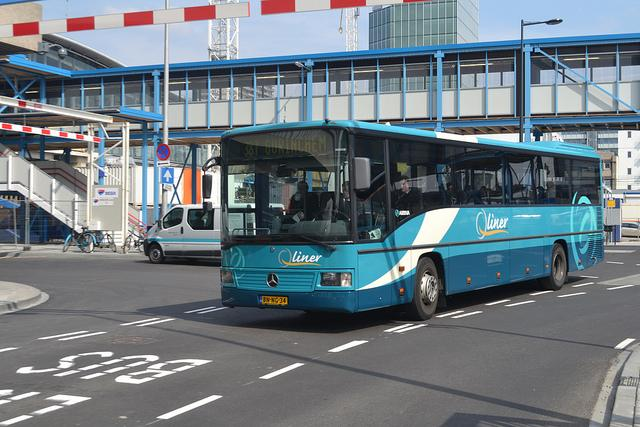What word is on the ground in white letters?

Choices:
A) bus
B) good
C) left
D) car bus 